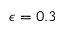<formula> <loc_0><loc_0><loc_500><loc_500>\epsilon = 0 . 3</formula> 